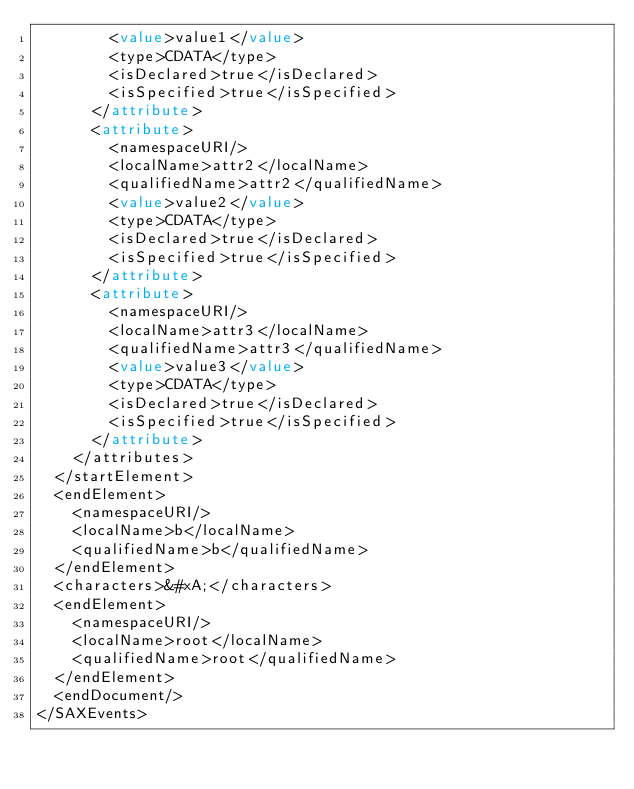<code> <loc_0><loc_0><loc_500><loc_500><_XML_>        <value>value1</value>
        <type>CDATA</type>
        <isDeclared>true</isDeclared>
        <isSpecified>true</isSpecified>
      </attribute>
      <attribute>
        <namespaceURI/>
        <localName>attr2</localName>
        <qualifiedName>attr2</qualifiedName>
        <value>value2</value>
        <type>CDATA</type>
        <isDeclared>true</isDeclared>
        <isSpecified>true</isSpecified>
      </attribute>
      <attribute>
        <namespaceURI/>
        <localName>attr3</localName>
        <qualifiedName>attr3</qualifiedName>
        <value>value3</value>
        <type>CDATA</type>
        <isDeclared>true</isDeclared>
        <isSpecified>true</isSpecified>
      </attribute>
    </attributes>
  </startElement>
  <endElement>
    <namespaceURI/>
    <localName>b</localName>
    <qualifiedName>b</qualifiedName>
  </endElement>
  <characters>&#xA;</characters>
  <endElement>
    <namespaceURI/>
    <localName>root</localName>
    <qualifiedName>root</qualifiedName>
  </endElement>
  <endDocument/>
</SAXEvents>
</code> 